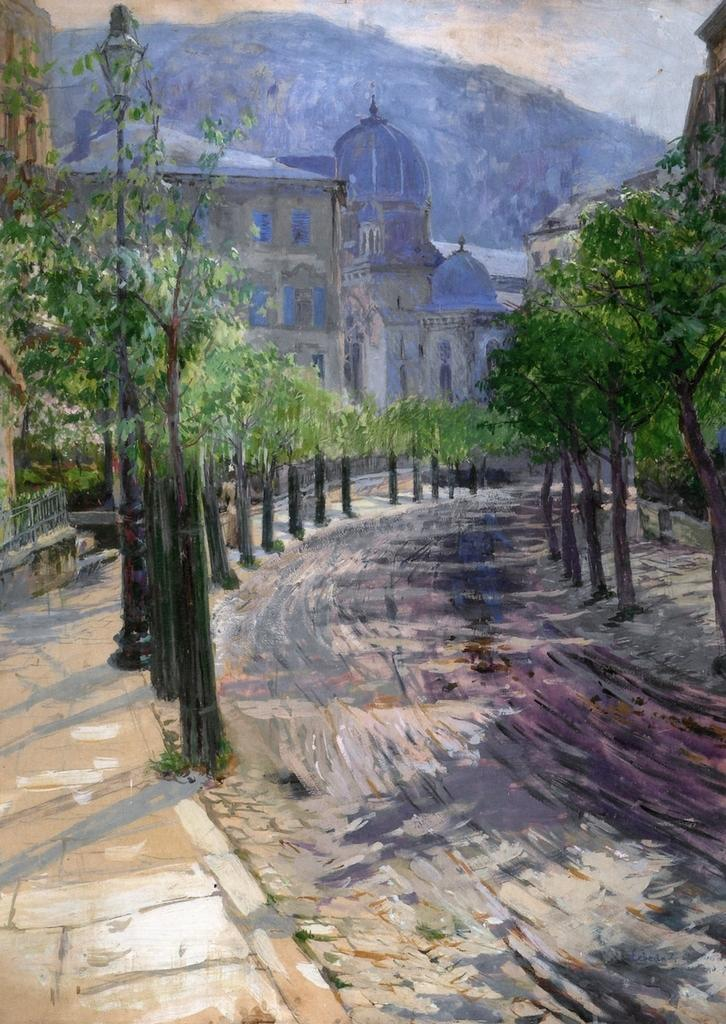What type of artwork is depicted in the image? The image is a painting. What natural elements can be seen in the painting? There are trees in the painting. What man-made structure is present in the painting? There is a road in the painting. What type of structures are visible in the background of the painting? There are buildings in the background of the painting. How much money is being offered in the painting? There is no indication of money or an offer being made in the painting. Is there a stream visible in the painting? There is no stream present in the painting; it features trees, a road, and buildings. 